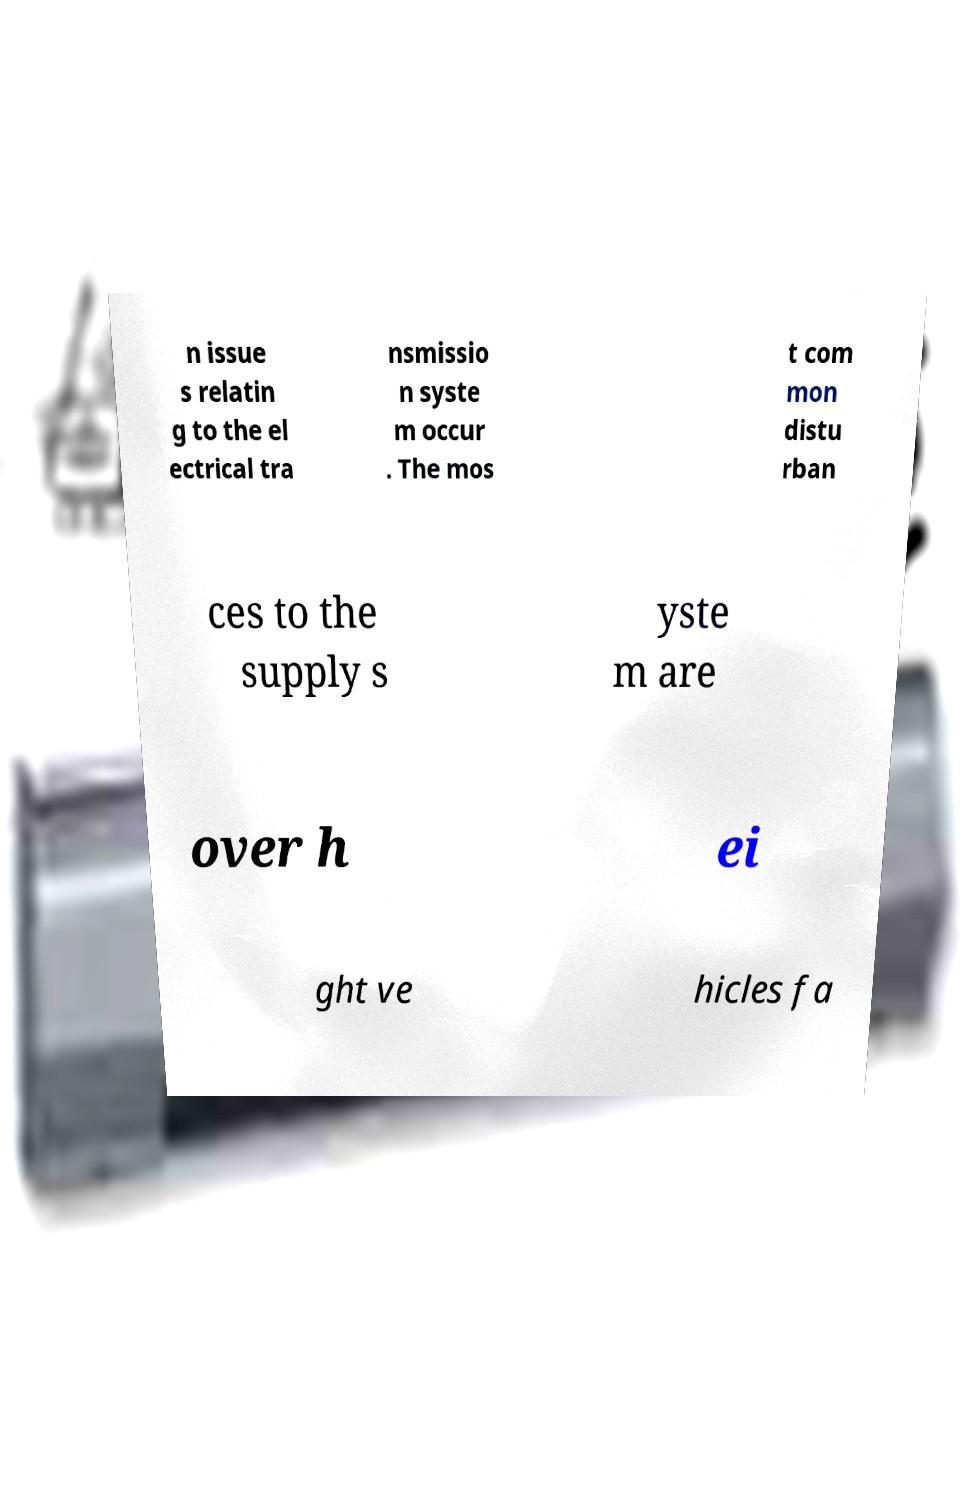I need the written content from this picture converted into text. Can you do that? n issue s relatin g to the el ectrical tra nsmissio n syste m occur . The mos t com mon distu rban ces to the supply s yste m are over h ei ght ve hicles fa 